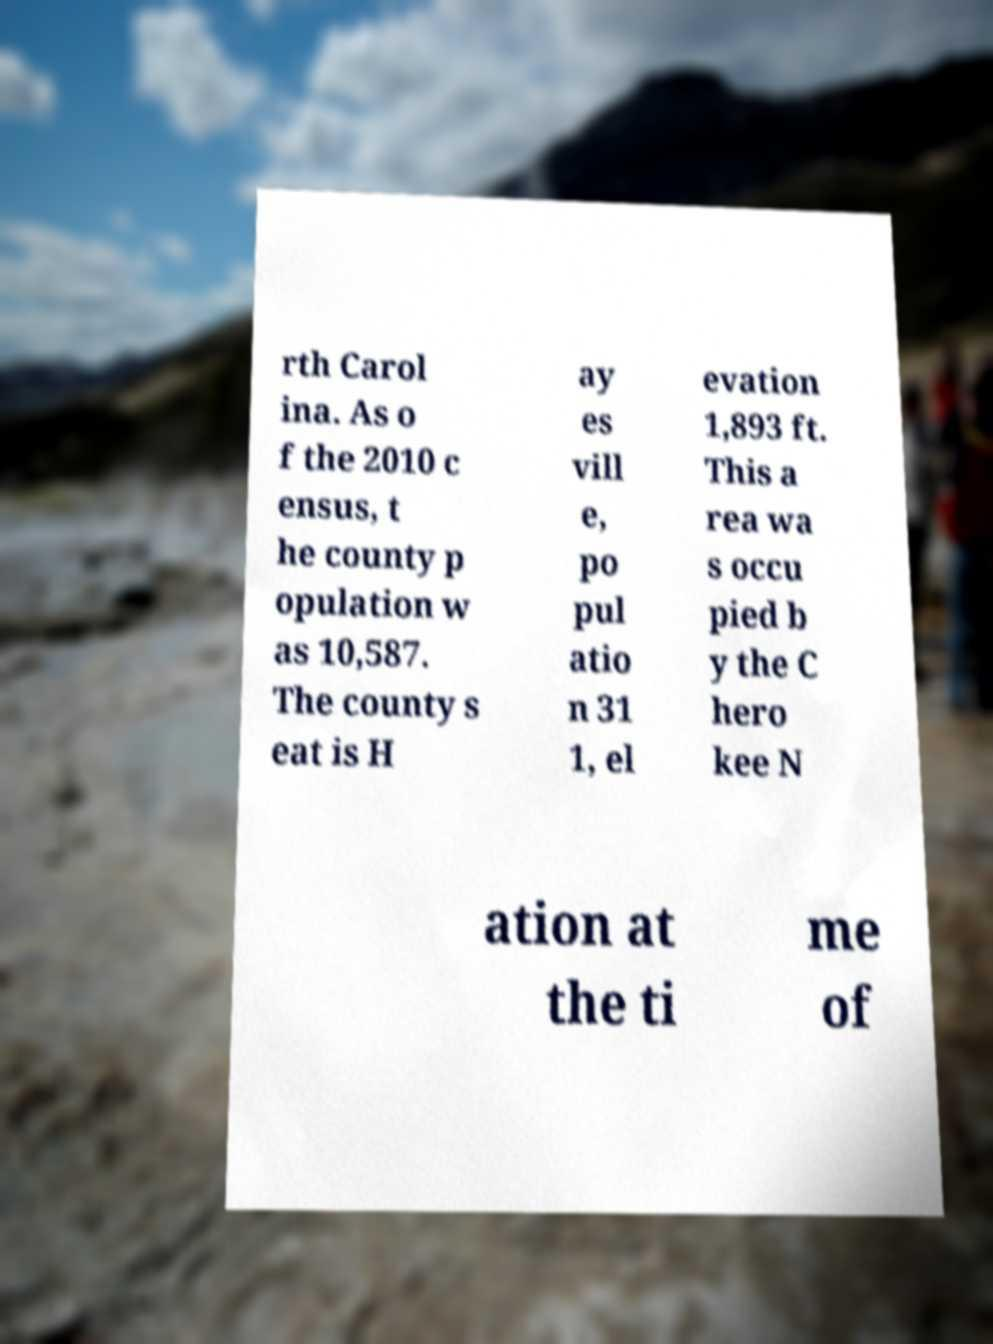Can you read and provide the text displayed in the image?This photo seems to have some interesting text. Can you extract and type it out for me? rth Carol ina. As o f the 2010 c ensus, t he county p opulation w as 10,587. The county s eat is H ay es vill e, po pul atio n 31 1, el evation 1,893 ft. This a rea wa s occu pied b y the C hero kee N ation at the ti me of 